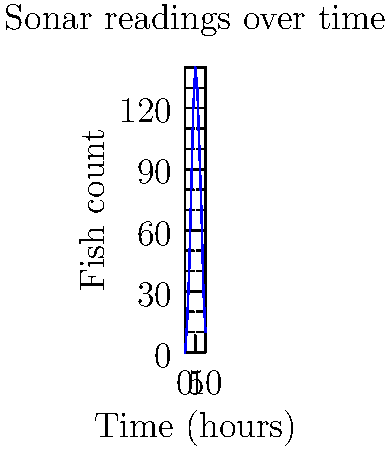Based on the sonar data visualization shown, at approximately what time does the fish count reach its peak? To determine when the fish count reaches its peak, we need to follow these steps:

1. Observe the graph: The x-axis represents time in hours, and the y-axis represents the fish count.

2. Identify the highest point: The curve reaches its maximum height somewhere in the middle of the graph.

3. Estimate the x-coordinate: The peak appears to occur around the 5-hour mark.

4. Verify: Before and after the 5-hour mark, the fish count is lower, confirming this as the peak.

5. Consider precision: Given the nature of sonar data and the graph's resolution, it's appropriate to estimate to the nearest hour.

Therefore, the fish count reaches its peak at approximately 5 hours after the start of the observation period.
Answer: 5 hours 